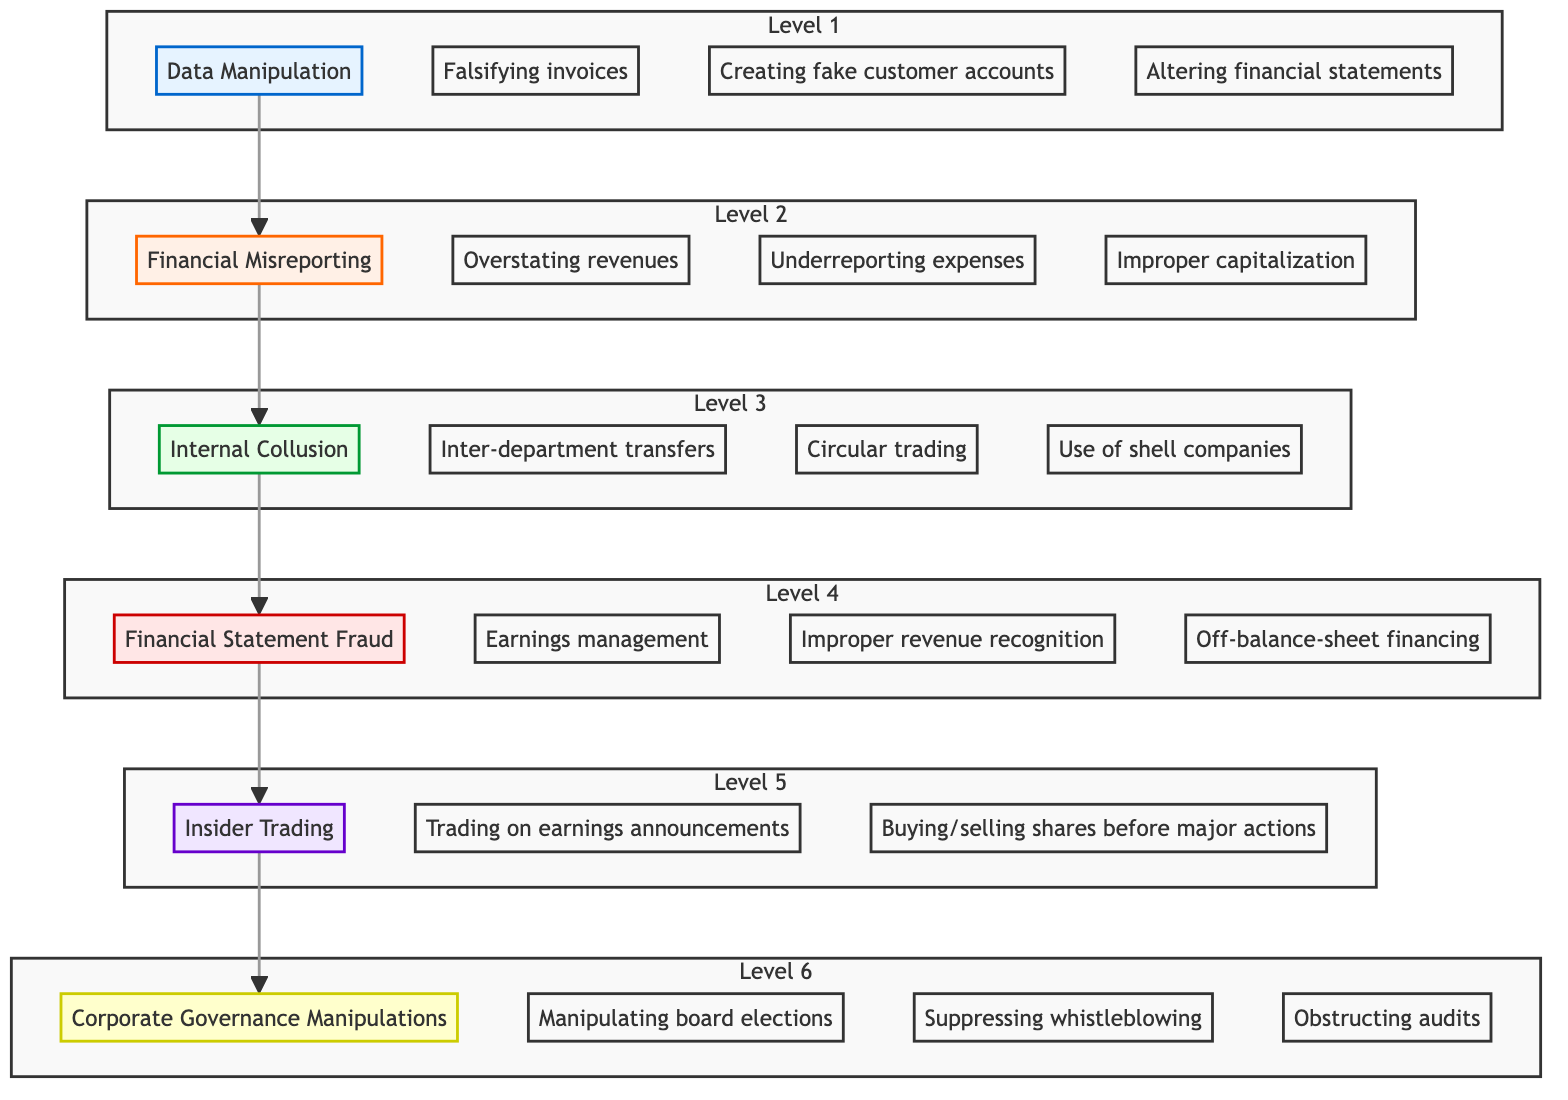What is the highest level in the hierarchy? The diagram indicates that the hierarchy culminates at "Corporate Governance Manipulations," which is classified as Level 6.
Answer: Corporate Governance Manipulations How many examples are listed under "Financial Statement Fraud"? Under the node "Financial Statement Fraud," three specific examples are provided, namely "Earnings management," "Improper revenue recognition," and "Off-balance-sheet financing."
Answer: 3 Which level describes low-level employees' actions? The first level of the diagram is designated as "Data Manipulation," which specifically refers to actions carried out by low-level employees.
Answer: Data Manipulation What is the relationship between "Internal Collusion" and "Financial Misreporting"? The diagram illustrates a direct upward connection from "Financial Misreporting" to "Internal Collusion," indicating that financial misreporting leads to or involves internal collusion.
Answer: Leads to Name one example of "Insider Trading." "Insider Trading" features the example of "Trading on earnings announcements" as a means of exploiting confidential information.
Answer: Trading on earnings announcements Which types of fraud occur at the executive level? The final two levels, specifically "Insider Trading" and "Corporate Governance Manipulations," represent fraud schemes perpetrated at the executive level.
Answer: Insider Trading and Corporate Governance Manipulations How many levels are represented in this flow chart? The flow chart consists of a total of six distinct levels, which encapsulate various types of corporate fraud, ranging from low-level manipulations to highest-level schemes.
Answer: 6 What does "Data Manipulation" lead to? "Data Manipulation" is positioned at the bottom of the hierarchy, and according to the flow chart, it directly leads to "Financial Misreporting," indicating the progression from data manipulation to higher-level fraudulent activities.
Answer: Financial Misreporting Which level focuses on collusion between departments? The third level, "Internal Collusion," focuses specifically on the collaborative efforts between departments to conceal irregularities through various means.
Answer: Internal Collusion What happens at the point of "Corporate Governance Manipulations"? At "Corporate Governance Manipulations," the diagram indicates a systemic manipulation of corporate culture by executives to further perpetrate fraud while evading detection.
Answer: Corporate culture manipulation 